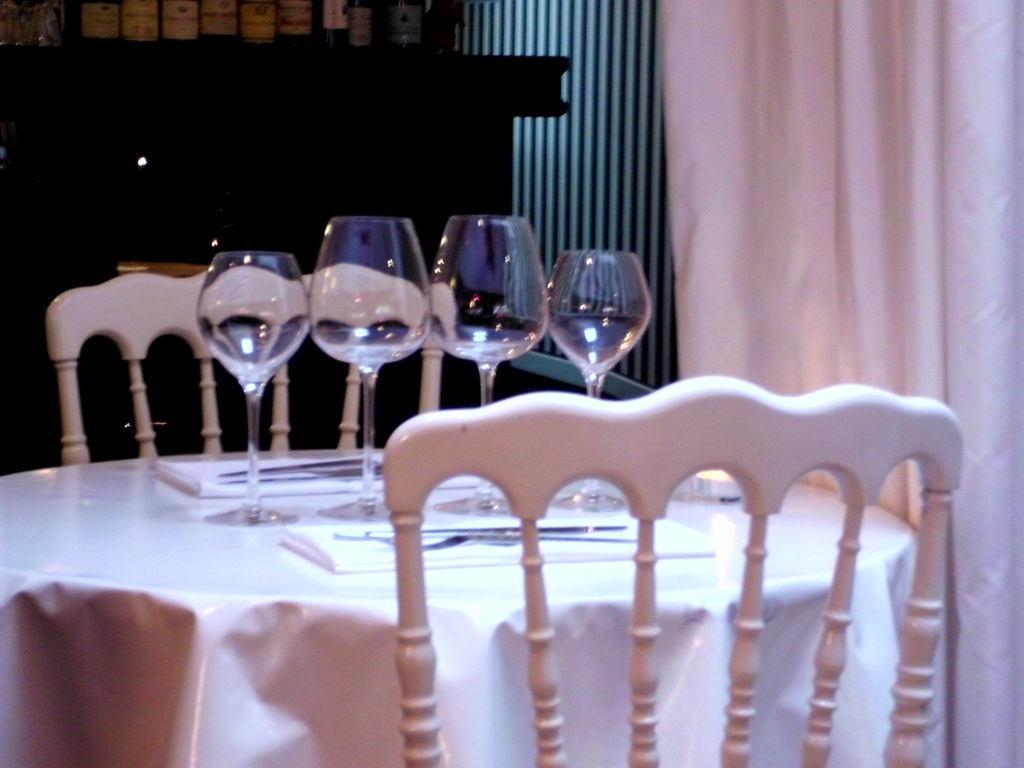In one or two sentences, can you explain what this image depicts? In this image I can see four glasses on a table. I can also see two chairs. 